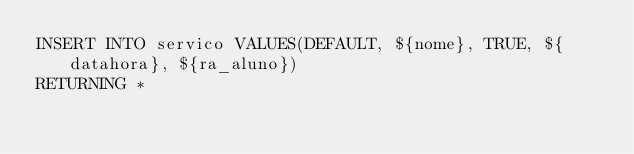<code> <loc_0><loc_0><loc_500><loc_500><_SQL_>INSERT INTO servico VALUES(DEFAULT, ${nome}, TRUE, ${datahora}, ${ra_aluno})
RETURNING *</code> 